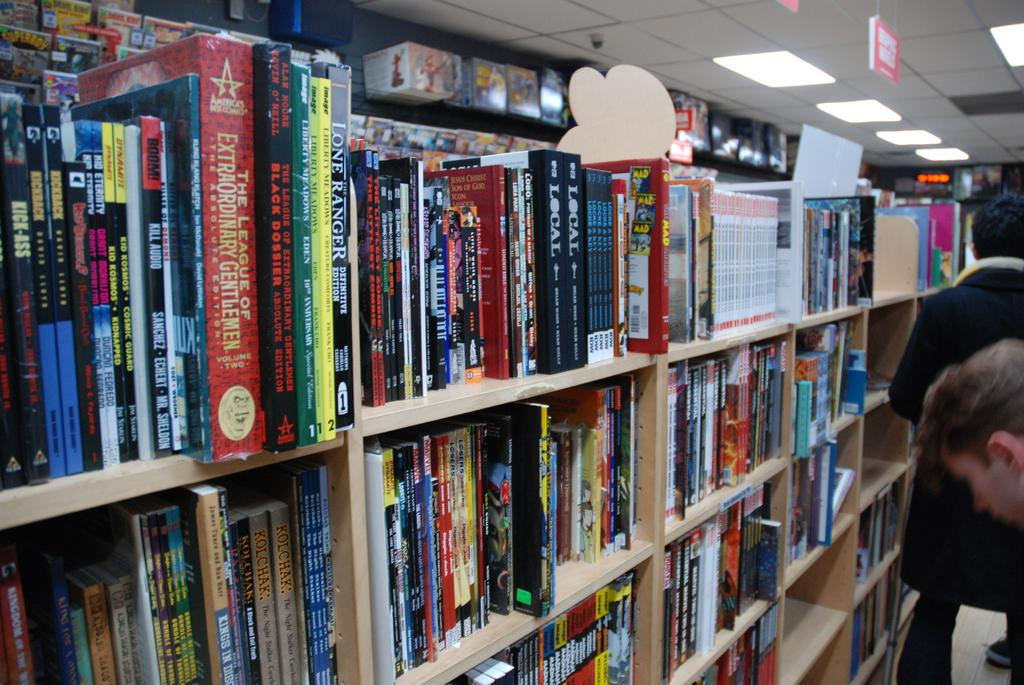What can be seen in the racks in the image? There are many books arranged in the racks. What type of place might the image depict? The setting appears to be a library. Can you describe the people in the image? There are two persons on the right side of the image. What is providing illumination in the image? There are lights near the roof at the top of the image. What type of balls can be seen on the shelf in the image? There are no balls present on the shelf in the image; it contains books. What type of exchange is taking place between the two persons in the image? There is no exchange taking place between the two persons in the image; they are simply standing on the right side. 